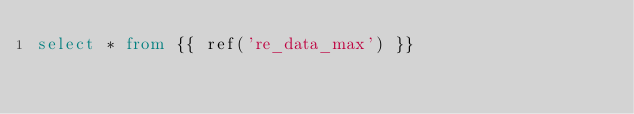Convert code to text. <code><loc_0><loc_0><loc_500><loc_500><_SQL_>select * from {{ ref('re_data_max') }}</code> 